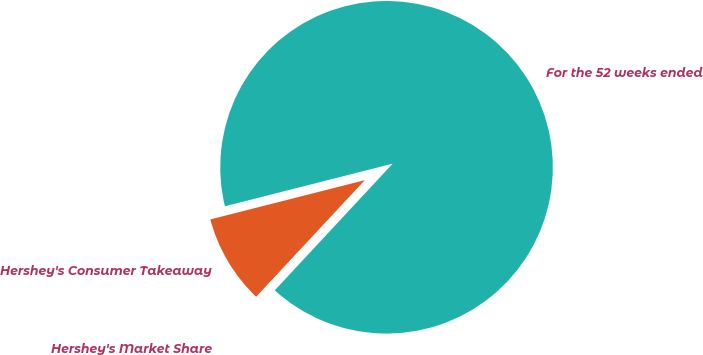Convert chart to OTSL. <chart><loc_0><loc_0><loc_500><loc_500><pie_chart><fcel>For the 52 weeks ended<fcel>Hershey's Consumer Takeaway<fcel>Hershey's Market Share<nl><fcel>90.89%<fcel>9.1%<fcel>0.01%<nl></chart> 